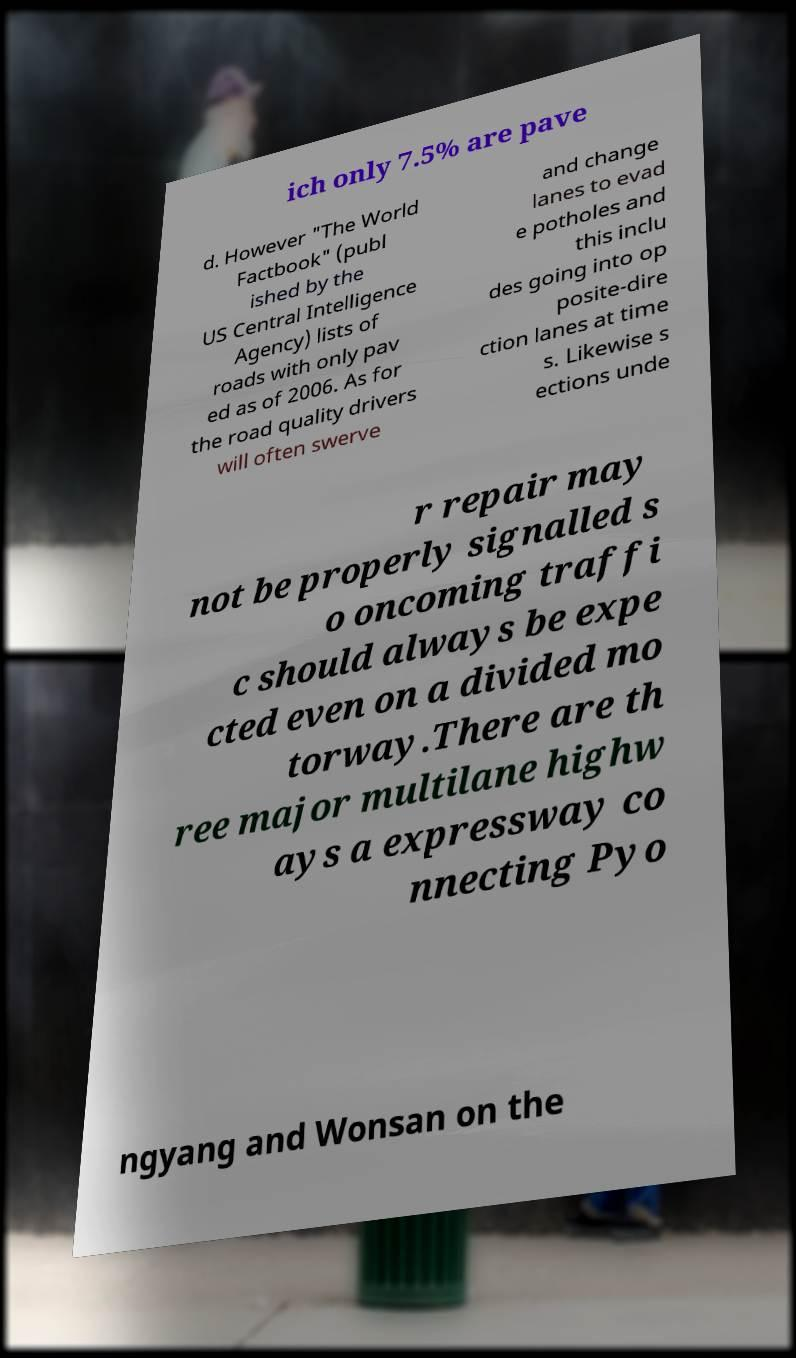I need the written content from this picture converted into text. Can you do that? ich only 7.5% are pave d. However "The World Factbook" (publ ished by the US Central Intelligence Agency) lists of roads with only pav ed as of 2006. As for the road quality drivers will often swerve and change lanes to evad e potholes and this inclu des going into op posite-dire ction lanes at time s. Likewise s ections unde r repair may not be properly signalled s o oncoming traffi c should always be expe cted even on a divided mo torway.There are th ree major multilane highw ays a expressway co nnecting Pyo ngyang and Wonsan on the 